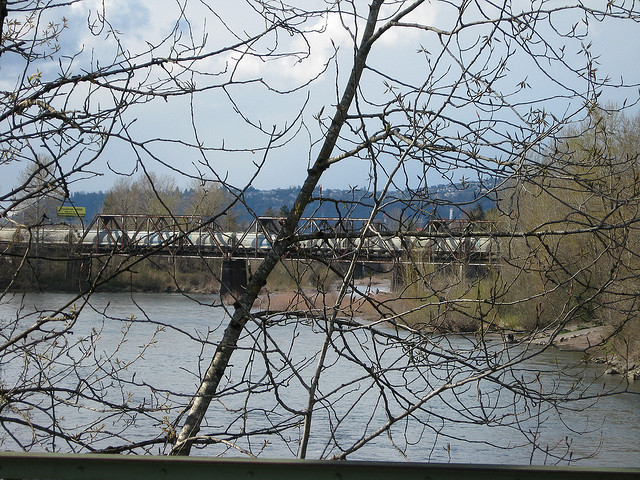<image>What is on the bridge? I cannot confidently tell you what is on the bridge. It could be a train or it could be people. What type of fencing is in the scene? I am not sure what type of fencing is in the scene. It can be metal, iron, steel or there might be no fencing. What is on the bridge? I don't know what is on the bridge. It can be seen trains or people. What type of fencing is in the scene? I don't know what type of fencing is in the scene. It can be seen as 'train', 'stone', 'railing', 'metal', 'iron', 'none', 'steel', or 'rail'. 